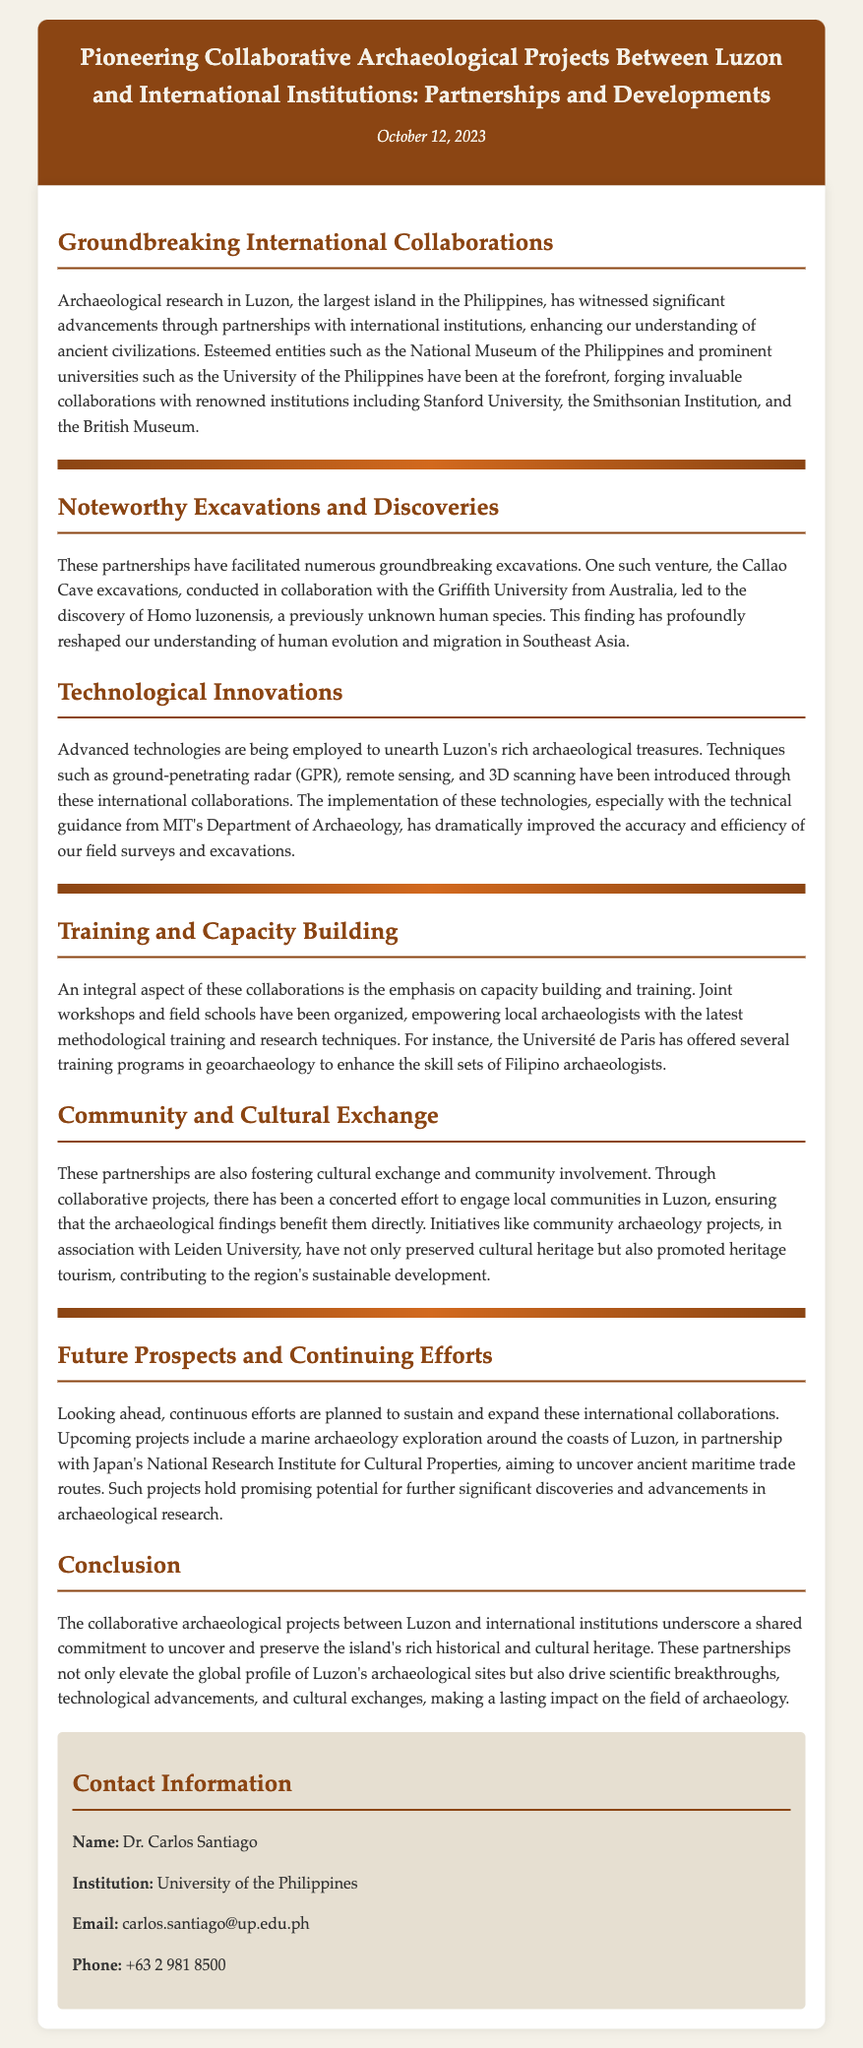What date was the press release issued? The date of the press release is mentioned at the top of the document.
Answer: October 12, 2023 Which human species was discovered during the Callao Cave excavations? The document refers to a specific discovery made during the excavations in collaboration with Griffith University.
Answer: Homo luzonensis What is one of the technologies introduced through these collaborations? The document lists several technologies used in archaeological research as a result of the collaborations.
Answer: Ground-penetrating radar Which institution provided training programs in geoarchaeology? The press release mentions an institution that offered specific training programs for local archaeologists.
Answer: Université de Paris What is the aim of the upcoming marine archaeology exploration? The document describes a future project outlining its objective related to maritime trade routes.
Answer: Uncover ancient maritime trade routes What type of projects have engaged local communities in Luzon? The press release highlights initiatives aimed at involving local communities in archaeological findings.
Answer: Community archaeology projects Which international institution is mentioned as partnering for the marine archaeology exploration? The document specifies a Japanese institution involved in future archaeological explorations.
Answer: Japan's National Research Institute for Cultural Properties What is a key goal of the collaborative projects mentioned in the press release? The document outlines the primary aim of these partnerships regarding historical and cultural heritage.
Answer: Uncover and preserve the island's rich historical and cultural heritage 